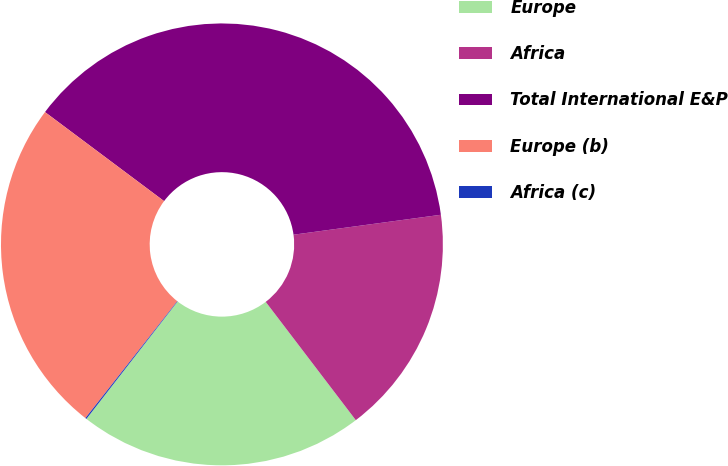Convert chart to OTSL. <chart><loc_0><loc_0><loc_500><loc_500><pie_chart><fcel>Europe<fcel>Africa<fcel>Total International E&P<fcel>Europe (b)<fcel>Africa (c)<nl><fcel>20.87%<fcel>16.78%<fcel>37.64%<fcel>24.62%<fcel>0.09%<nl></chart> 